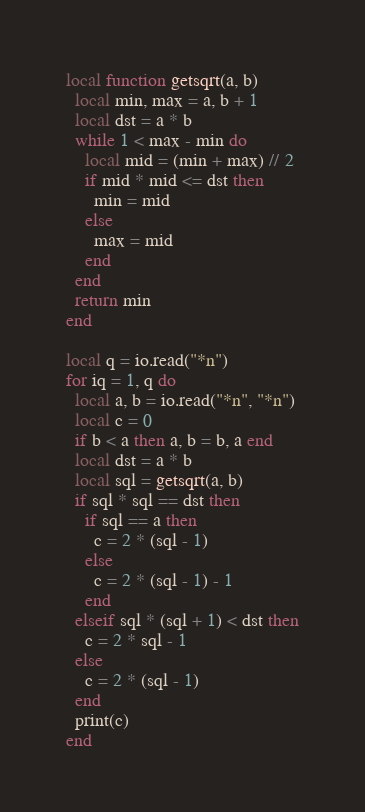Convert code to text. <code><loc_0><loc_0><loc_500><loc_500><_Lua_>local function getsqrt(a, b)
  local min, max = a, b + 1
  local dst = a * b
  while 1 < max - min do
    local mid = (min + max) // 2
    if mid * mid <= dst then
      min = mid
    else
      max = mid
    end
  end
  return min
end

local q = io.read("*n")
for iq = 1, q do
  local a, b = io.read("*n", "*n")
  local c = 0
  if b < a then a, b = b, a end
  local dst = a * b
  local sql = getsqrt(a, b)
  if sql * sql == dst then
    if sql == a then
      c = 2 * (sql - 1)
    else
      c = 2 * (sql - 1) - 1
    end
  elseif sql * (sql + 1) < dst then
    c = 2 * sql - 1
  else
    c = 2 * (sql - 1)
  end
  print(c)
end
</code> 